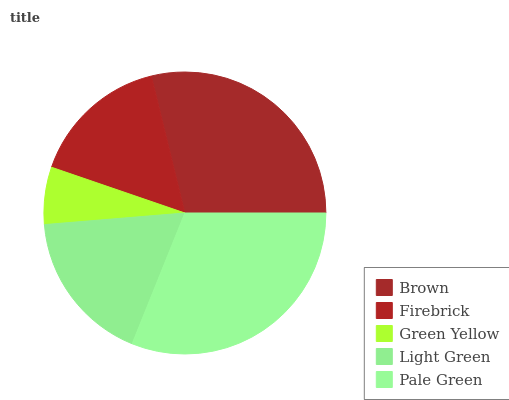Is Green Yellow the minimum?
Answer yes or no. Yes. Is Pale Green the maximum?
Answer yes or no. Yes. Is Firebrick the minimum?
Answer yes or no. No. Is Firebrick the maximum?
Answer yes or no. No. Is Brown greater than Firebrick?
Answer yes or no. Yes. Is Firebrick less than Brown?
Answer yes or no. Yes. Is Firebrick greater than Brown?
Answer yes or no. No. Is Brown less than Firebrick?
Answer yes or no. No. Is Light Green the high median?
Answer yes or no. Yes. Is Light Green the low median?
Answer yes or no. Yes. Is Pale Green the high median?
Answer yes or no. No. Is Firebrick the low median?
Answer yes or no. No. 